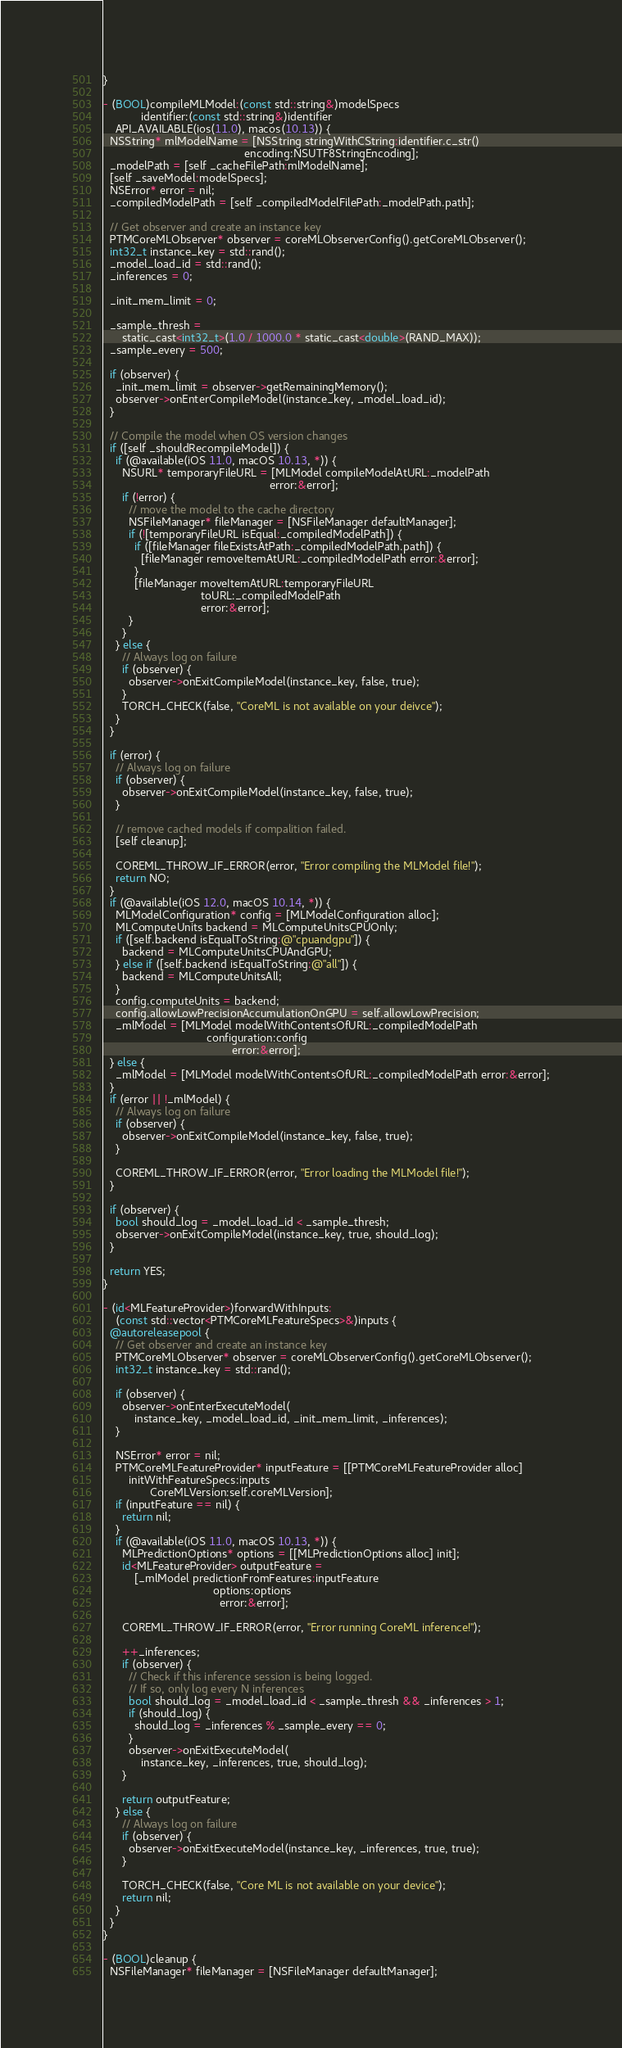<code> <loc_0><loc_0><loc_500><loc_500><_ObjectiveC_>}

- (BOOL)compileMLModel:(const std::string&)modelSpecs
            identifier:(const std::string&)identifier
    API_AVAILABLE(ios(11.0), macos(10.13)) {
  NSString* mlModelName = [NSString stringWithCString:identifier.c_str()
                                             encoding:NSUTF8StringEncoding];
  _modelPath = [self _cacheFilePath:mlModelName];
  [self _saveModel:modelSpecs];
  NSError* error = nil;
  _compiledModelPath = [self _compiledModelFilePath:_modelPath.path];

  // Get observer and create an instance key
  PTMCoreMLObserver* observer = coreMLObserverConfig().getCoreMLObserver();
  int32_t instance_key = std::rand();
  _model_load_id = std::rand();
  _inferences = 0;

  _init_mem_limit = 0;

  _sample_thresh =
      static_cast<int32_t>(1.0 / 1000.0 * static_cast<double>(RAND_MAX));
  _sample_every = 500;

  if (observer) {
    _init_mem_limit = observer->getRemainingMemory();
    observer->onEnterCompileModel(instance_key, _model_load_id);
  }

  // Compile the model when OS version changes
  if ([self _shouldRecompileModel]) {
    if (@available(iOS 11.0, macOS 10.13, *)) {
      NSURL* temporaryFileURL = [MLModel compileModelAtURL:_modelPath
                                                     error:&error];
      if (!error) {
        // move the model to the cache directory
        NSFileManager* fileManager = [NSFileManager defaultManager];
        if (![temporaryFileURL isEqual:_compiledModelPath]) {
          if ([fileManager fileExistsAtPath:_compiledModelPath.path]) {
            [fileManager removeItemAtURL:_compiledModelPath error:&error];
          }
          [fileManager moveItemAtURL:temporaryFileURL
                               toURL:_compiledModelPath
                               error:&error];
        }
      }
    } else {
      // Always log on failure
      if (observer) {
        observer->onExitCompileModel(instance_key, false, true);
      }
      TORCH_CHECK(false, "CoreML is not available on your deivce");
    }
  }

  if (error) {
    // Always log on failure
    if (observer) {
      observer->onExitCompileModel(instance_key, false, true);
    }

    // remove cached models if compalition failed.
    [self cleanup];

    COREML_THROW_IF_ERROR(error, "Error compiling the MLModel file!");
    return NO;
  }
  if (@available(iOS 12.0, macOS 10.14, *)) {
    MLModelConfiguration* config = [MLModelConfiguration alloc];
    MLComputeUnits backend = MLComputeUnitsCPUOnly;
    if ([self.backend isEqualToString:@"cpuandgpu"]) {
      backend = MLComputeUnitsCPUAndGPU;
    } else if ([self.backend isEqualToString:@"all"]) {
      backend = MLComputeUnitsAll;
    }
    config.computeUnits = backend;
    config.allowLowPrecisionAccumulationOnGPU = self.allowLowPrecision;
    _mlModel = [MLModel modelWithContentsOfURL:_compiledModelPath
                                 configuration:config
                                         error:&error];
  } else {
    _mlModel = [MLModel modelWithContentsOfURL:_compiledModelPath error:&error];
  }
  if (error || !_mlModel) {
    // Always log on failure
    if (observer) {
      observer->onExitCompileModel(instance_key, false, true);
    }

    COREML_THROW_IF_ERROR(error, "Error loading the MLModel file!");
  }

  if (observer) {
    bool should_log = _model_load_id < _sample_thresh;
    observer->onExitCompileModel(instance_key, true, should_log);
  }

  return YES;
}

- (id<MLFeatureProvider>)forwardWithInputs:
    (const std::vector<PTMCoreMLFeatureSpecs>&)inputs {
  @autoreleasepool {
    // Get observer and create an instance key
    PTMCoreMLObserver* observer = coreMLObserverConfig().getCoreMLObserver();
    int32_t instance_key = std::rand();

    if (observer) {
      observer->onEnterExecuteModel(
          instance_key, _model_load_id, _init_mem_limit, _inferences);
    }

    NSError* error = nil;
    PTMCoreMLFeatureProvider* inputFeature = [[PTMCoreMLFeatureProvider alloc]
        initWithFeatureSpecs:inputs
               CoreMLVersion:self.coreMLVersion];
    if (inputFeature == nil) {
      return nil;
    }
    if (@available(iOS 11.0, macOS 10.13, *)) {
      MLPredictionOptions* options = [[MLPredictionOptions alloc] init];
      id<MLFeatureProvider> outputFeature =
          [_mlModel predictionFromFeatures:inputFeature
                                   options:options
                                     error:&error];

      COREML_THROW_IF_ERROR(error, "Error running CoreML inference!");

      ++_inferences;
      if (observer) {
        // Check if this inference session is being logged.
        // If so, only log every N inferences
        bool should_log = _model_load_id < _sample_thresh && _inferences > 1;
        if (should_log) {
          should_log = _inferences % _sample_every == 0;
        }
        observer->onExitExecuteModel(
            instance_key, _inferences, true, should_log);
      }

      return outputFeature;
    } else {
      // Always log on failure
      if (observer) {
        observer->onExitExecuteModel(instance_key, _inferences, true, true);
      }

      TORCH_CHECK(false, "Core ML is not available on your device");
      return nil;
    }
  }
}

- (BOOL)cleanup {
  NSFileManager* fileManager = [NSFileManager defaultManager];</code> 